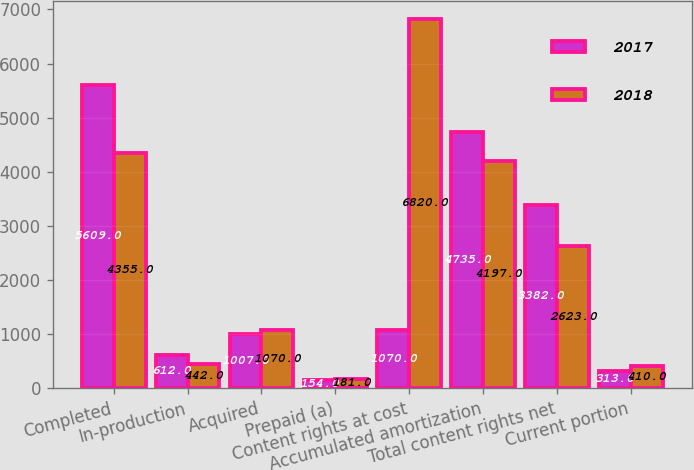<chart> <loc_0><loc_0><loc_500><loc_500><stacked_bar_chart><ecel><fcel>Completed<fcel>In-production<fcel>Acquired<fcel>Prepaid (a)<fcel>Content rights at cost<fcel>Accumulated amortization<fcel>Total content rights net<fcel>Current portion<nl><fcel>2017<fcel>5609<fcel>612<fcel>1007<fcel>154<fcel>1070<fcel>4735<fcel>3382<fcel>313<nl><fcel>2018<fcel>4355<fcel>442<fcel>1070<fcel>181<fcel>6820<fcel>4197<fcel>2623<fcel>410<nl></chart> 